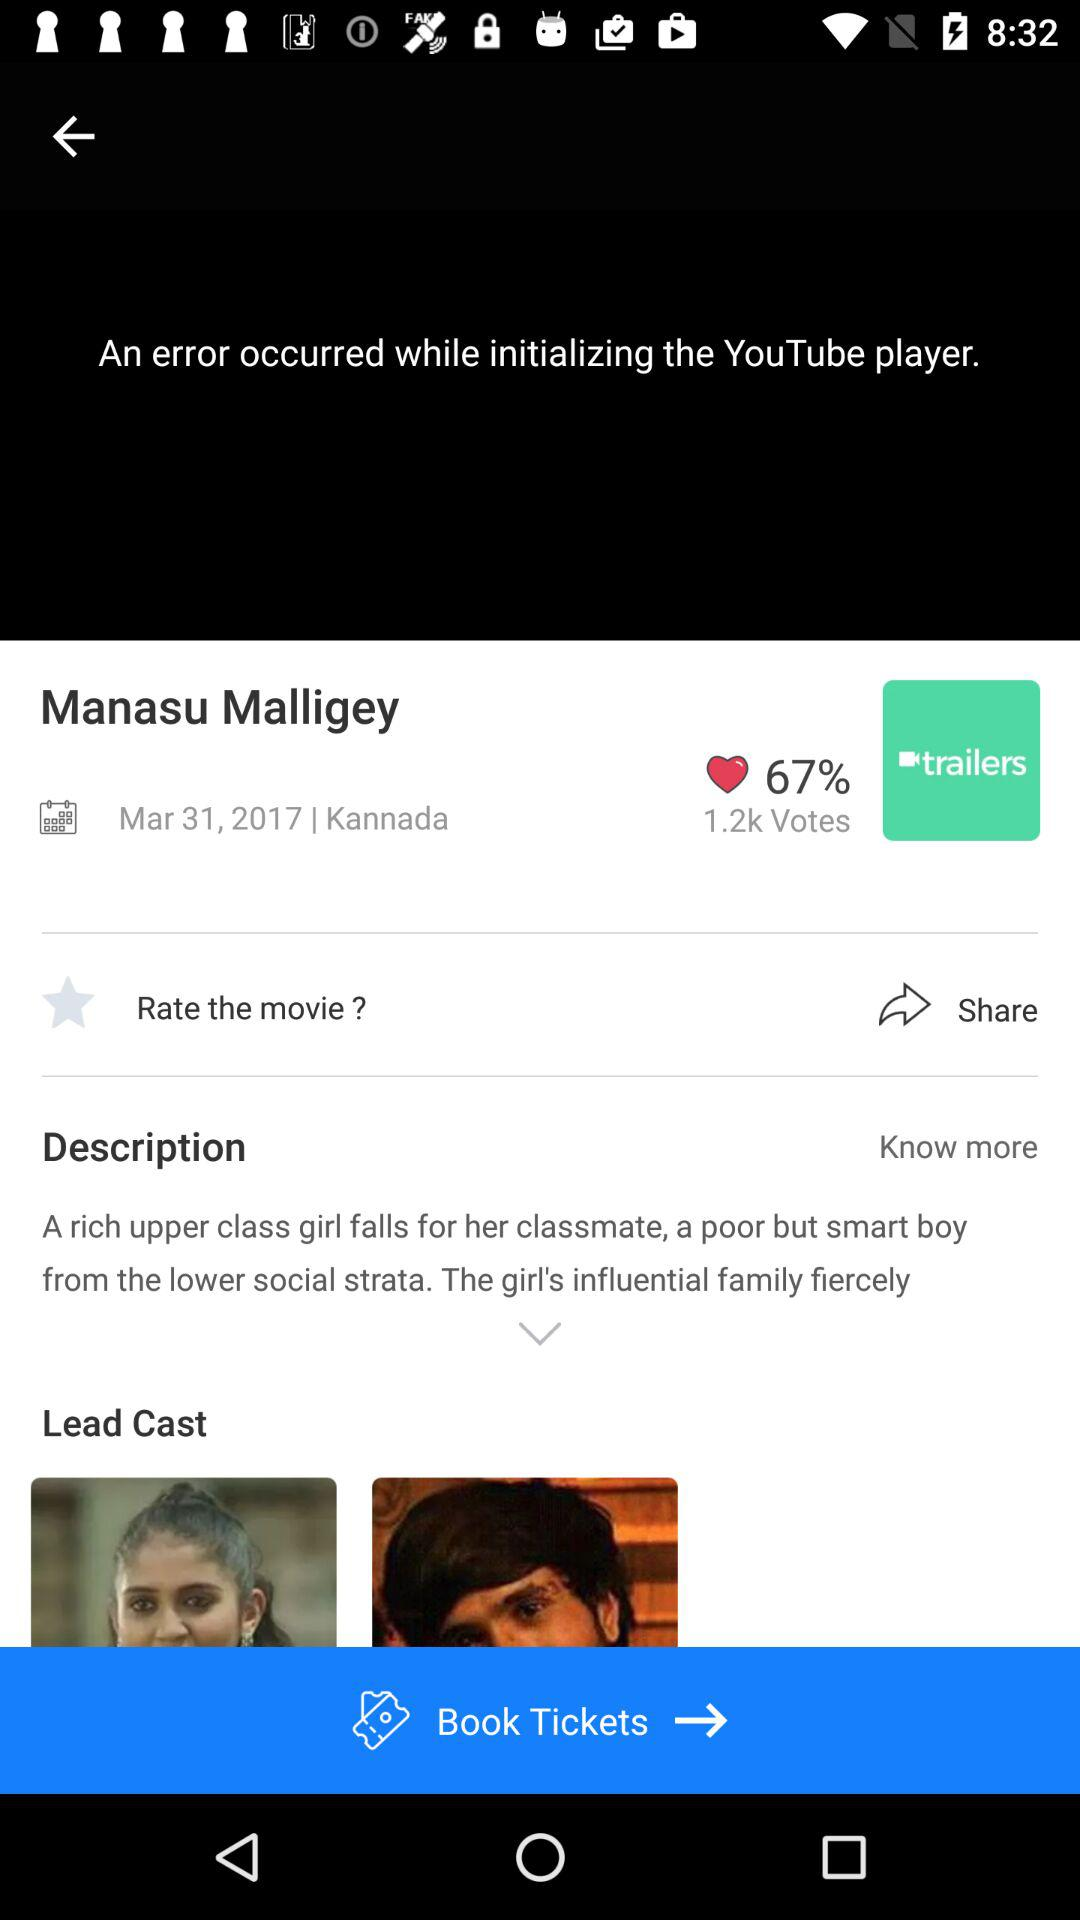What is the name of the movie? The name of the movie is "Manasu Malligey". 